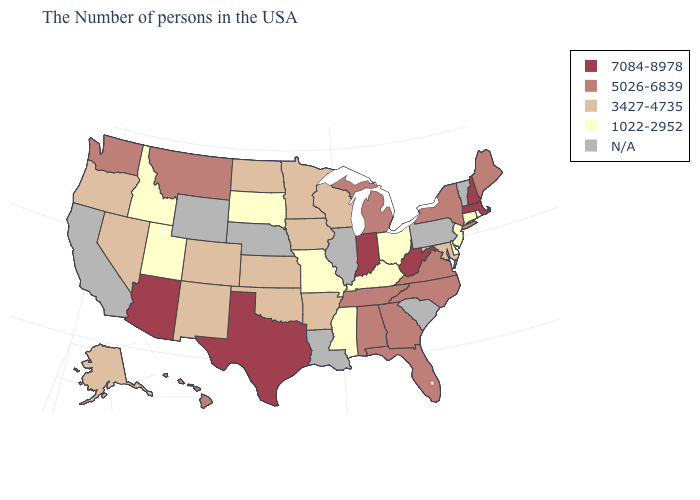Does the first symbol in the legend represent the smallest category?
Give a very brief answer. No. Among the states that border Kansas , which have the lowest value?
Write a very short answer. Missouri. Name the states that have a value in the range 3427-4735?
Write a very short answer. Maryland, Wisconsin, Arkansas, Minnesota, Iowa, Kansas, Oklahoma, North Dakota, Colorado, New Mexico, Nevada, Oregon, Alaska. What is the lowest value in the MidWest?
Quick response, please. 1022-2952. What is the value of Louisiana?
Write a very short answer. N/A. Name the states that have a value in the range 5026-6839?
Be succinct. Maine, New York, Virginia, North Carolina, Florida, Georgia, Michigan, Alabama, Tennessee, Montana, Washington, Hawaii. Among the states that border Nevada , which have the highest value?
Answer briefly. Arizona. Which states have the highest value in the USA?
Give a very brief answer. Massachusetts, New Hampshire, West Virginia, Indiana, Texas, Arizona. Which states have the highest value in the USA?
Write a very short answer. Massachusetts, New Hampshire, West Virginia, Indiana, Texas, Arizona. Which states have the lowest value in the USA?
Keep it brief. Rhode Island, Connecticut, New Jersey, Delaware, Ohio, Kentucky, Mississippi, Missouri, South Dakota, Utah, Idaho. Name the states that have a value in the range 1022-2952?
Short answer required. Rhode Island, Connecticut, New Jersey, Delaware, Ohio, Kentucky, Mississippi, Missouri, South Dakota, Utah, Idaho. What is the highest value in states that border Tennessee?
Short answer required. 5026-6839. What is the value of California?
Quick response, please. N/A. 